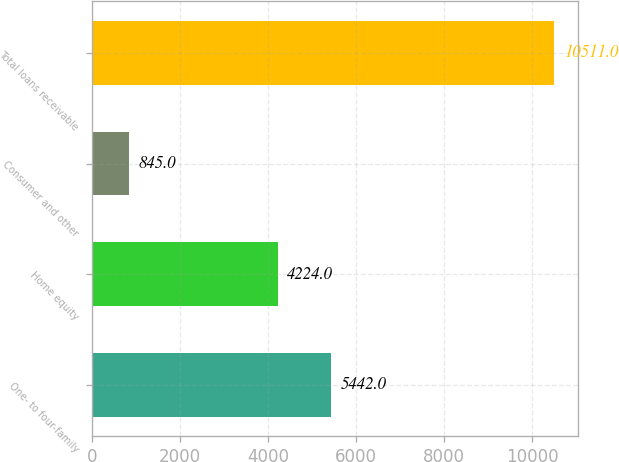<chart> <loc_0><loc_0><loc_500><loc_500><bar_chart><fcel>One- to four-family<fcel>Home equity<fcel>Consumer and other<fcel>Total loans receivable<nl><fcel>5442<fcel>4224<fcel>845<fcel>10511<nl></chart> 